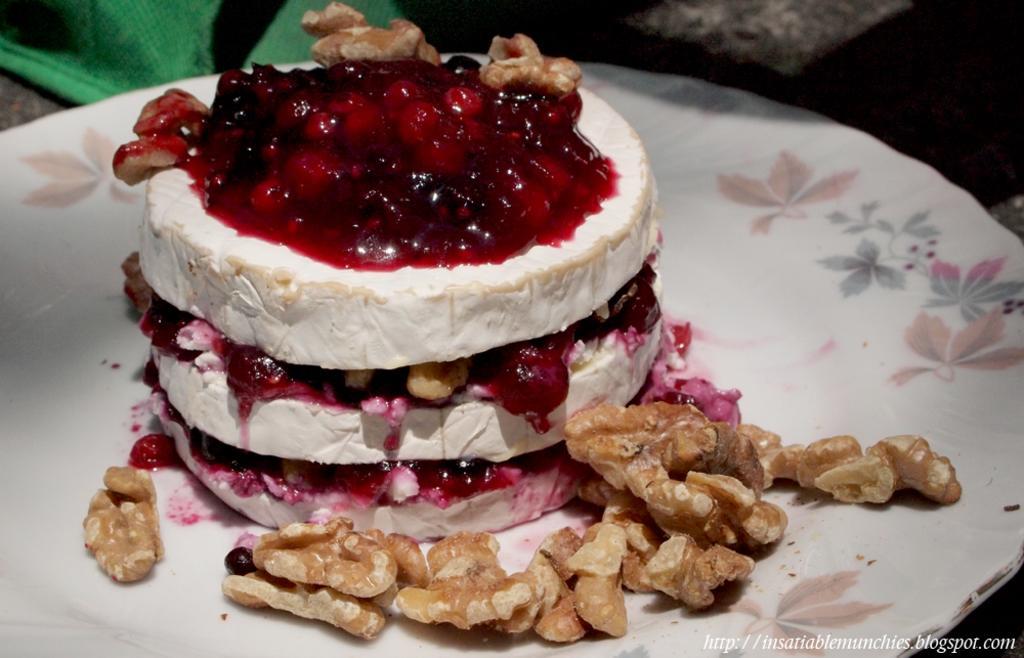In one or two sentences, can you explain what this image depicts? In this image we can see the food item which looks like a cake with nuts in a plate and we can see some objects at the top of the image. 